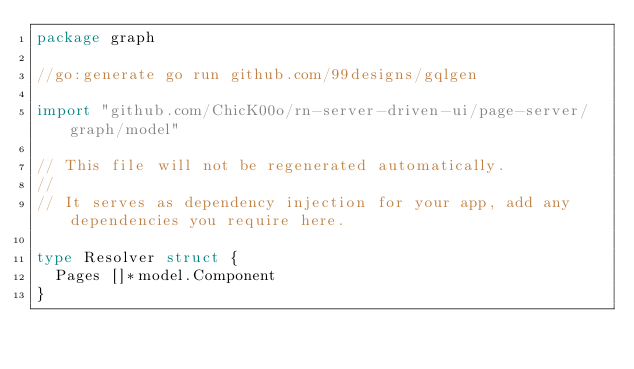Convert code to text. <code><loc_0><loc_0><loc_500><loc_500><_Go_>package graph

//go:generate go run github.com/99designs/gqlgen

import "github.com/ChicK00o/rn-server-driven-ui/page-server/graph/model"

// This file will not be regenerated automatically.
//
// It serves as dependency injection for your app, add any dependencies you require here.

type Resolver struct {
	Pages []*model.Component
}
</code> 